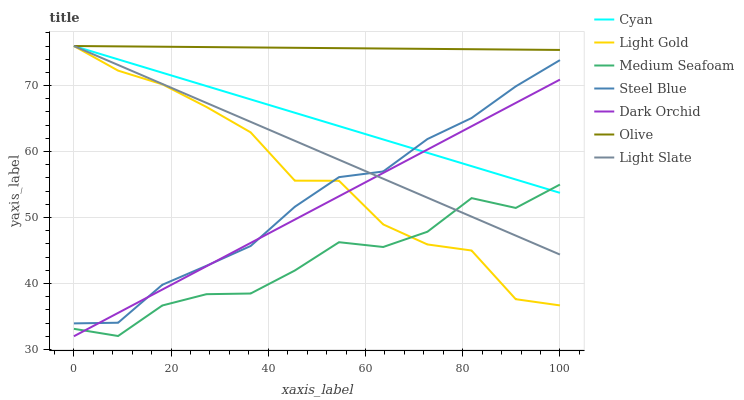Does Medium Seafoam have the minimum area under the curve?
Answer yes or no. Yes. Does Olive have the maximum area under the curve?
Answer yes or no. Yes. Does Steel Blue have the minimum area under the curve?
Answer yes or no. No. Does Steel Blue have the maximum area under the curve?
Answer yes or no. No. Is Cyan the smoothest?
Answer yes or no. Yes. Is Light Gold the roughest?
Answer yes or no. Yes. Is Steel Blue the smoothest?
Answer yes or no. No. Is Steel Blue the roughest?
Answer yes or no. No. Does Dark Orchid have the lowest value?
Answer yes or no. Yes. Does Steel Blue have the lowest value?
Answer yes or no. No. Does Light Gold have the highest value?
Answer yes or no. Yes. Does Steel Blue have the highest value?
Answer yes or no. No. Is Steel Blue less than Olive?
Answer yes or no. Yes. Is Steel Blue greater than Medium Seafoam?
Answer yes or no. Yes. Does Dark Orchid intersect Cyan?
Answer yes or no. Yes. Is Dark Orchid less than Cyan?
Answer yes or no. No. Is Dark Orchid greater than Cyan?
Answer yes or no. No. Does Steel Blue intersect Olive?
Answer yes or no. No. 